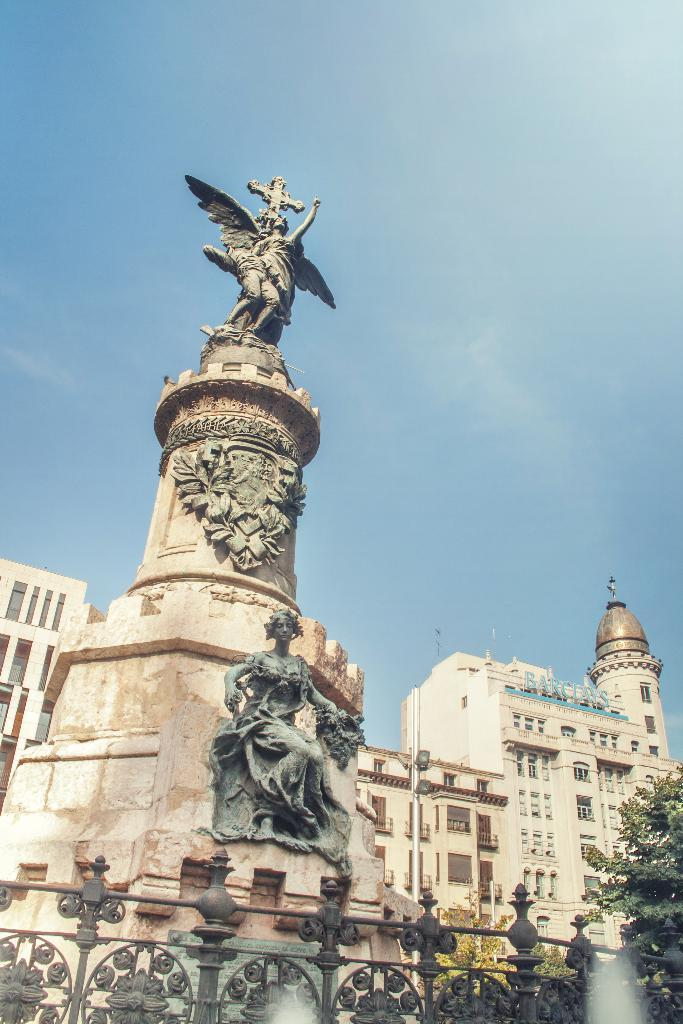What can be found in the middle of the image? There are statues and buildings in the middle of the image. Where is the tree located in the image? The tree is in the bottom right corner of the image. What is visible at the top of the image? The sky is visible at the top of the image. What type of lettuce is growing on the buildings in the image? There is no lettuce present in the image; it features statues, buildings, a tree, and the sky. Can you see a chair in the image? There is no chair present in the image. 